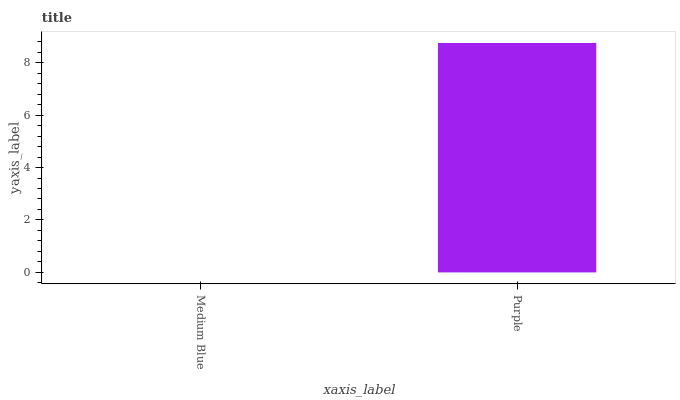Is Medium Blue the minimum?
Answer yes or no. Yes. Is Purple the maximum?
Answer yes or no. Yes. Is Purple the minimum?
Answer yes or no. No. Is Purple greater than Medium Blue?
Answer yes or no. Yes. Is Medium Blue less than Purple?
Answer yes or no. Yes. Is Medium Blue greater than Purple?
Answer yes or no. No. Is Purple less than Medium Blue?
Answer yes or no. No. Is Purple the high median?
Answer yes or no. Yes. Is Medium Blue the low median?
Answer yes or no. Yes. Is Medium Blue the high median?
Answer yes or no. No. Is Purple the low median?
Answer yes or no. No. 